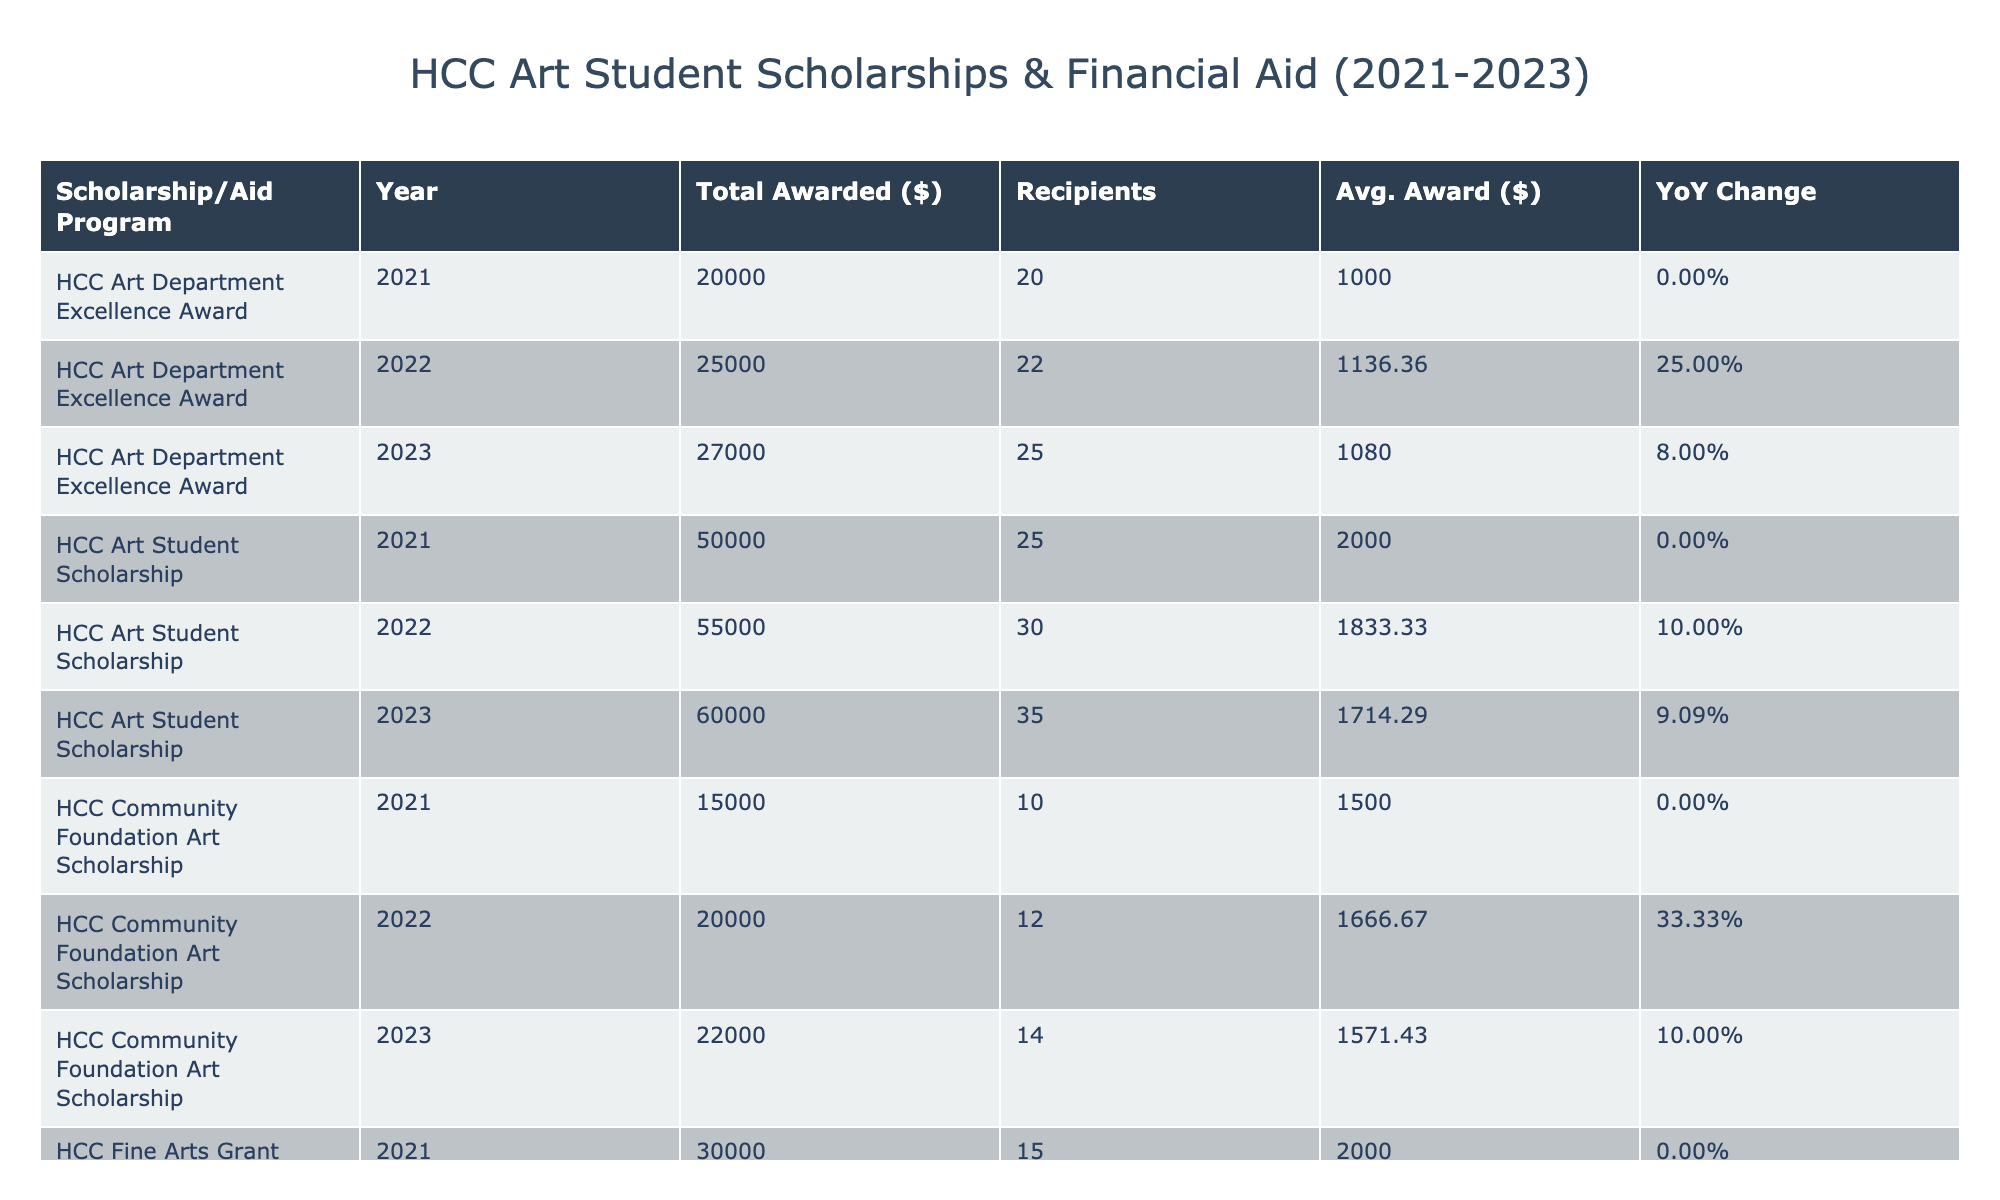What was the total amount awarded for the HCC Presidential Scholarship in 2023? In the table, I can find the HCC Presidential Scholarship row for the year 2023. The Total Awarded Amount for that row is listed as 90000.
Answer: 90000 What is the average award amount for the HCC Community Foundation Art Scholarship in 2022? The Average Award Amount for the HCC Community Foundation Art Scholarship in 2022 is directly listed in the table as 1666.67.
Answer: 1666.67 How many total recipients were there for all scholarships in 2021? I need to look at each scholarship’s Number of Recipients for the year 2021. Adding them together: 25 (Art Student) + 15 (Fine Arts Grant) + 40 (Presidential) + 10 (Community Foundation) + 20 (Excellence Award) gives a total of 110 recipients.
Answer: 110 Did the total awarded amount for the HCC Art Department Excellence Award increase from 2021 to 2022? In 2021, the Total Awarded Amount for the HCC Art Department Excellence Award is 20000. In 2022, it increased to 25000. Since 25000 is greater than 20000, the total awarded amount did increase.
Answer: Yes What was the year-on-year change percentage for the HCC Fine Arts Grant from 2021 to 2022? For the HCC Fine Arts Grant, the Total Awarded Amount in 2021 was 30000 and in 2022 it was 32000. To find the percentage change, I calculate: (32000 - 30000) / 30000 = 0.06667, which is approximately 6.67%.
Answer: 6.67% Which scholarship had the highest average award amount in 2023, and what was that amount? Checking the Average Award Amount for each scholarship in 2023, I observe: 1714.29 (Art Student), 2000 (Fine Arts Grant), 1800 (Presidential), 1571.43 (Community Foundation), and 1080 (Excellence Award). The highest is 2000 for the HCC Fine Arts Grant.
Answer: HCC Fine Arts Grant, 2000 How many more recipients did the HCC Presidential Scholarship have in 2023 compared to 2021? In 2023, the number of recipients for the HCC Presidential Scholarship is 50, and in 2021 it was 40. The difference is 50 - 40 = 10.
Answer: 10 What is the total awarded amount for the HCC Art Student Scholarship across all the years listed? Adding the Total Awarded Amount for the HCC Art Student Scholarship from 2021 (50000), 2022 (55000), and 2023 (60000): 50000 + 55000 + 60000 = 165000.
Answer: 165000 Did the average award amount for the HCC Community Foundation Art Scholarship decrease from 2021 to 2022? In 2021, the Average Award Amount for the HCC Community Foundation Art Scholarship was 1500 and in 2022 it was 1666.67. Since 1666.67 is greater than 1500, it did not decrease.
Answer: No 